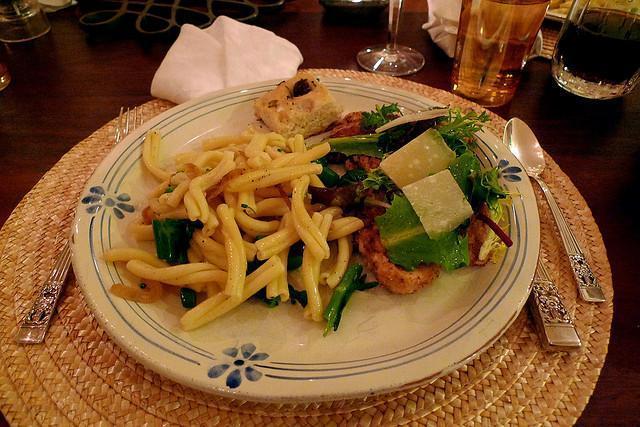How many cups are in the picture?
Give a very brief answer. 2. How many knives are there?
Give a very brief answer. 1. How many spoons are there?
Give a very brief answer. 2. 